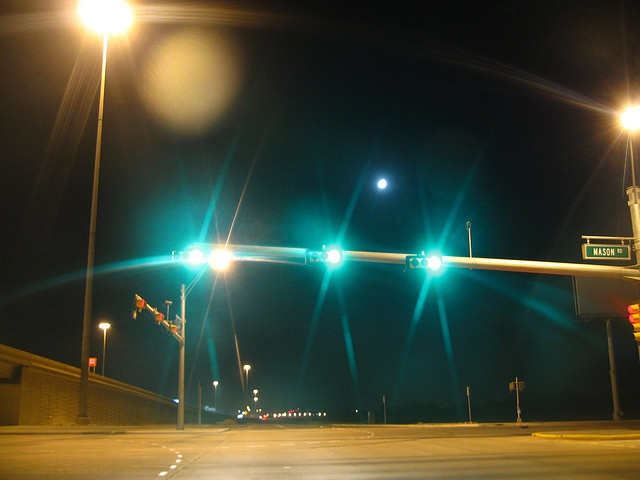Describe the objects in this image and their specific colors. I can see traffic light in maroon, ivory, cyan, and beige tones, traffic light in maroon, white, and turquoise tones, traffic light in maroon, white, turquoise, and teal tones, traffic light in maroon, black, orange, red, and brown tones, and traffic light in maroon, black, red, and tan tones in this image. 